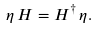<formula> <loc_0><loc_0><loc_500><loc_500>\eta \, H = H ^ { \dagger } \, \eta .</formula> 